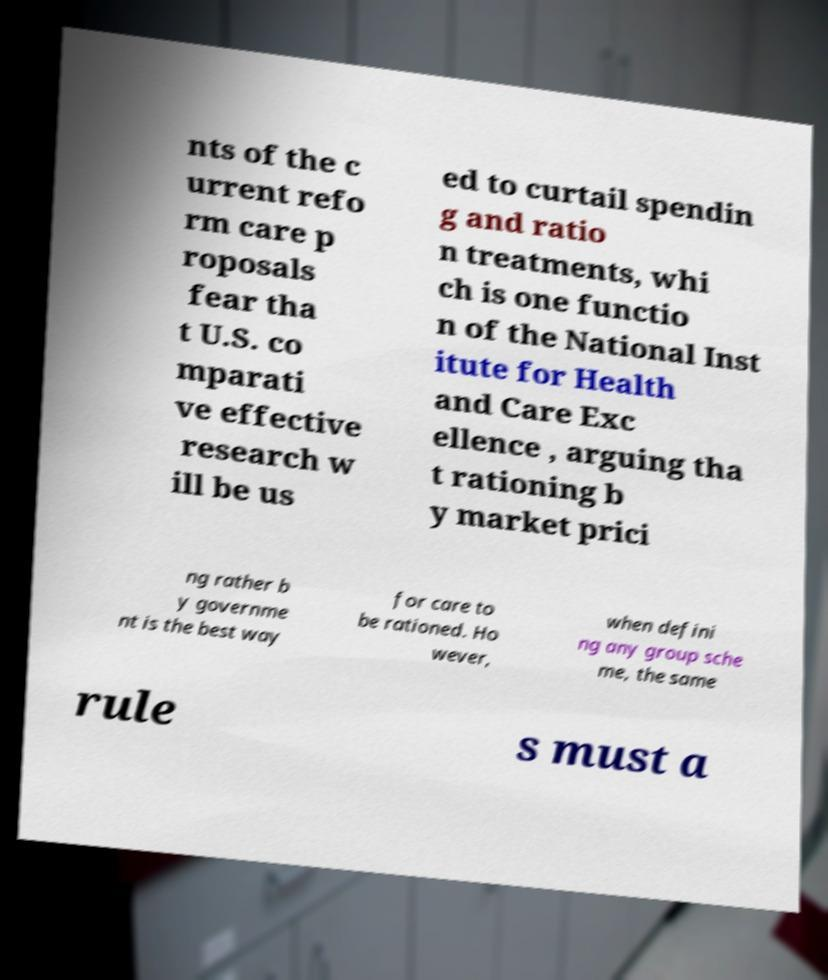Can you accurately transcribe the text from the provided image for me? nts of the c urrent refo rm care p roposals fear tha t U.S. co mparati ve effective research w ill be us ed to curtail spendin g and ratio n treatments, whi ch is one functio n of the National Inst itute for Health and Care Exc ellence , arguing tha t rationing b y market prici ng rather b y governme nt is the best way for care to be rationed. Ho wever, when defini ng any group sche me, the same rule s must a 